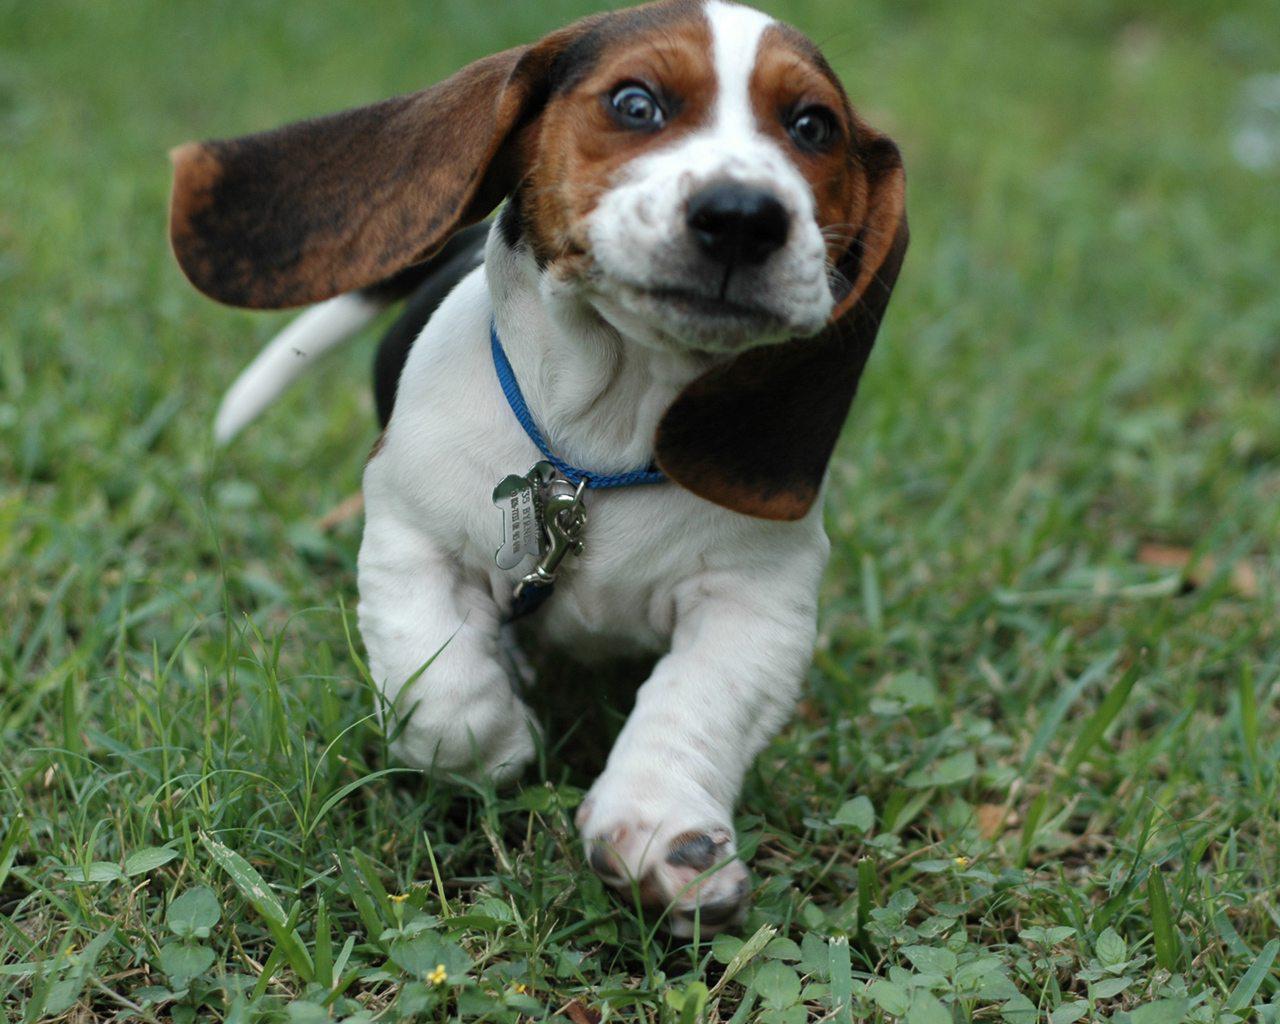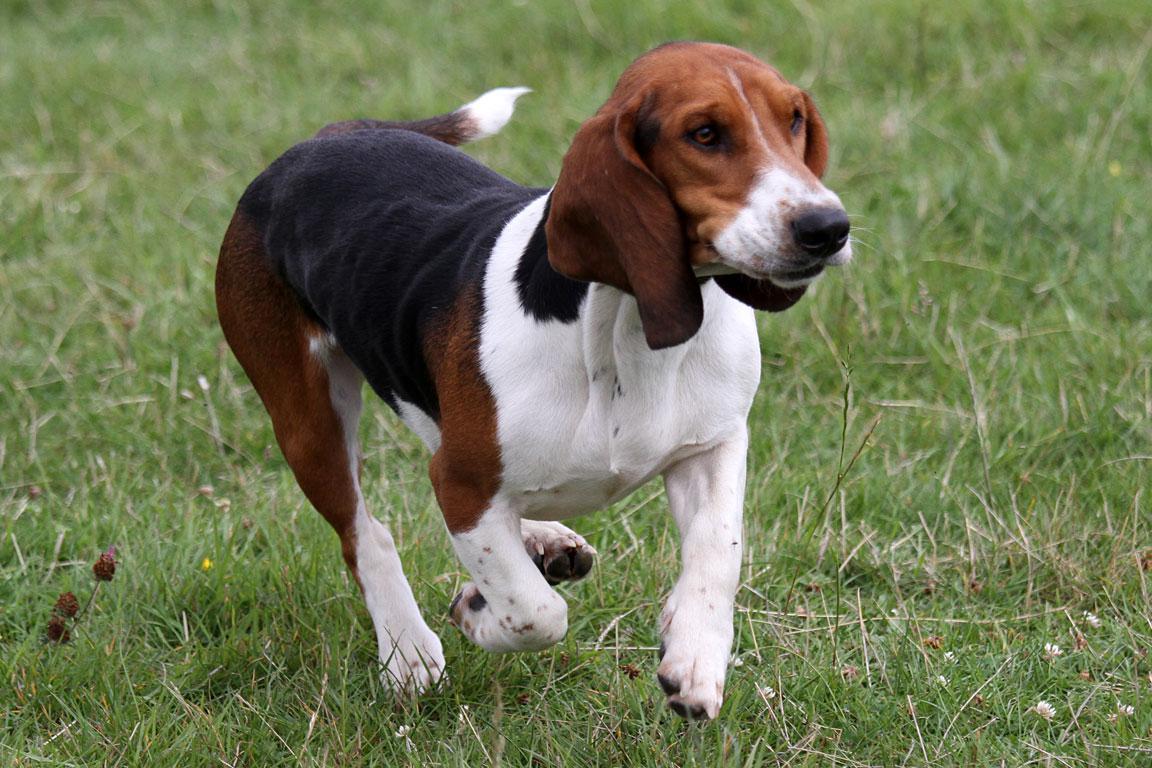The first image is the image on the left, the second image is the image on the right. Examine the images to the left and right. Is the description "There are two dogs" accurate? Answer yes or no. Yes. 